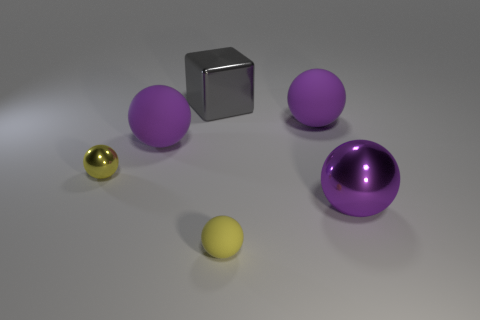Could you talk about the lighting and shadows in the image? Certainly. The lighting in the image is soft and diffuse, casting gentle shadows beneath the objects. This indicates the presence of an overhead light source, providing even illumination with minimal harshness. The shadows help give a sense of the spatial relationship between the items and the surface they are resting on. 